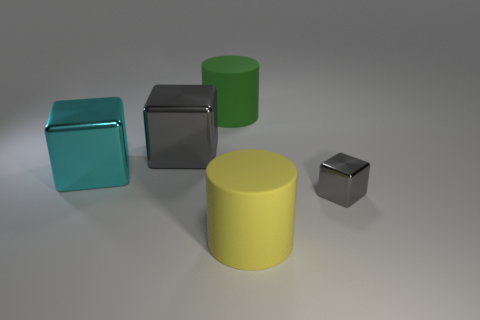How many large cubes are the same color as the tiny shiny object?
Keep it short and to the point. 1. There is a cylinder behind the matte cylinder in front of the thing left of the large gray thing; what is its material?
Your answer should be very brief. Rubber. What material is the other object that is the same shape as the yellow thing?
Ensure brevity in your answer.  Rubber. What color is the small block?
Your answer should be compact. Gray. The metal object that is right of the gray metallic object left of the tiny gray shiny object is what color?
Your answer should be very brief. Gray. There is a tiny object; does it have the same color as the rubber cylinder behind the big yellow rubber thing?
Give a very brief answer. No. There is a rubber object in front of the gray metallic block that is to the right of the green rubber cylinder; how many objects are to the right of it?
Your answer should be very brief. 1. There is a small gray block; are there any objects left of it?
Offer a terse response. Yes. Are there any other things that are the same color as the tiny cube?
Make the answer very short. Yes. How many cylinders are either large matte objects or big green rubber objects?
Keep it short and to the point. 2. 